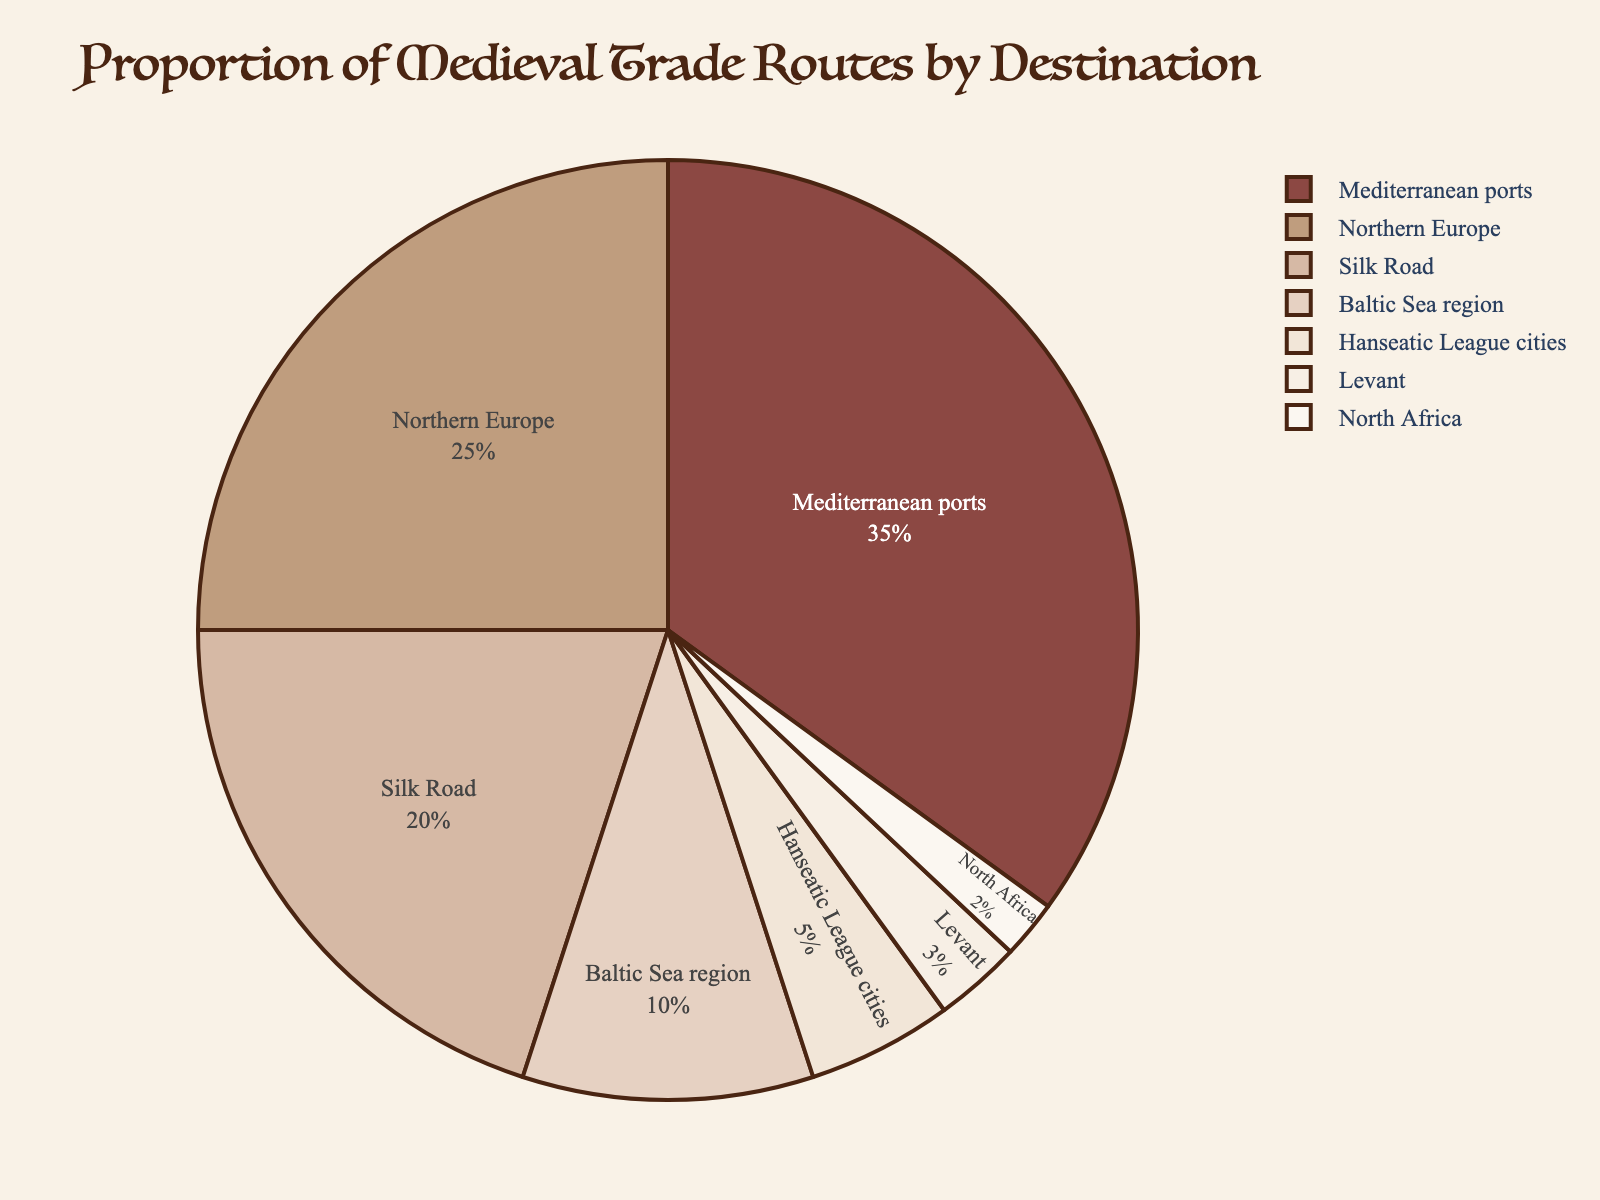What is the destination with the highest proportion of medieval trade routes? The Mediterranean ports have the largest slice on the pie chart, indicating the highest proportion of medieval trade routes.
Answer: Mediterranean ports What percentage of medieval trade routes are directed towards Northern Europe and the Baltic Sea region combined? The chart shows Northern Europe at 25% and the Baltic Sea region at 10%. Adding these percentages gives 25% + 10% = 35%.
Answer: 35% Which destination has a smaller proportion of medieval trade routes: the Levant or North Africa? The pie chart shows the Levant at 3% and North Africa at 2%. Thus, North Africa has a smaller proportion.
Answer: North Africa How much larger is the proportion of trade routes to the Mediterranean ports compared to the Silk Road? The chart shows the Mediterranean ports at 35% and the Silk Road at 20%. The difference is 35% - 20% = 15%.
Answer: 15% What is the combined percentage of the three smallest destinations by trade route proportion? The three smallest destinations are the Levant (3%), North Africa (2%), and Hanseatic League cities (5%). Their combined percentage is 3% + 2% + 5% = 10%.
Answer: 10% Which two destinations have the closest percentages of medieval trade routes, and what are their proportions? Northern Europe is at 25% and the Silk Road is at 20%. The difference is 25% - 20% = 5%, which is the smallest difference between any two slices.
Answer: Northern Europe (25%) and Silk Road (20%) What portion of the medieval trade routes is directed towards destinations other than the Mediterranean ports? The Mediterranean ports have 35%, so the proportion to other destinations is 100% - 35% = 65%.
Answer: 65% How does the proportion of trade routes to the Baltic Sea region compare to those directed towards the Hanseatic League cities? The pie chart shows the Baltic Sea region at 10% and the Hanseatic League cities at 5%. The Baltic Sea region has a higher proportion.
Answer: The Baltic Sea region has a higher proportion 